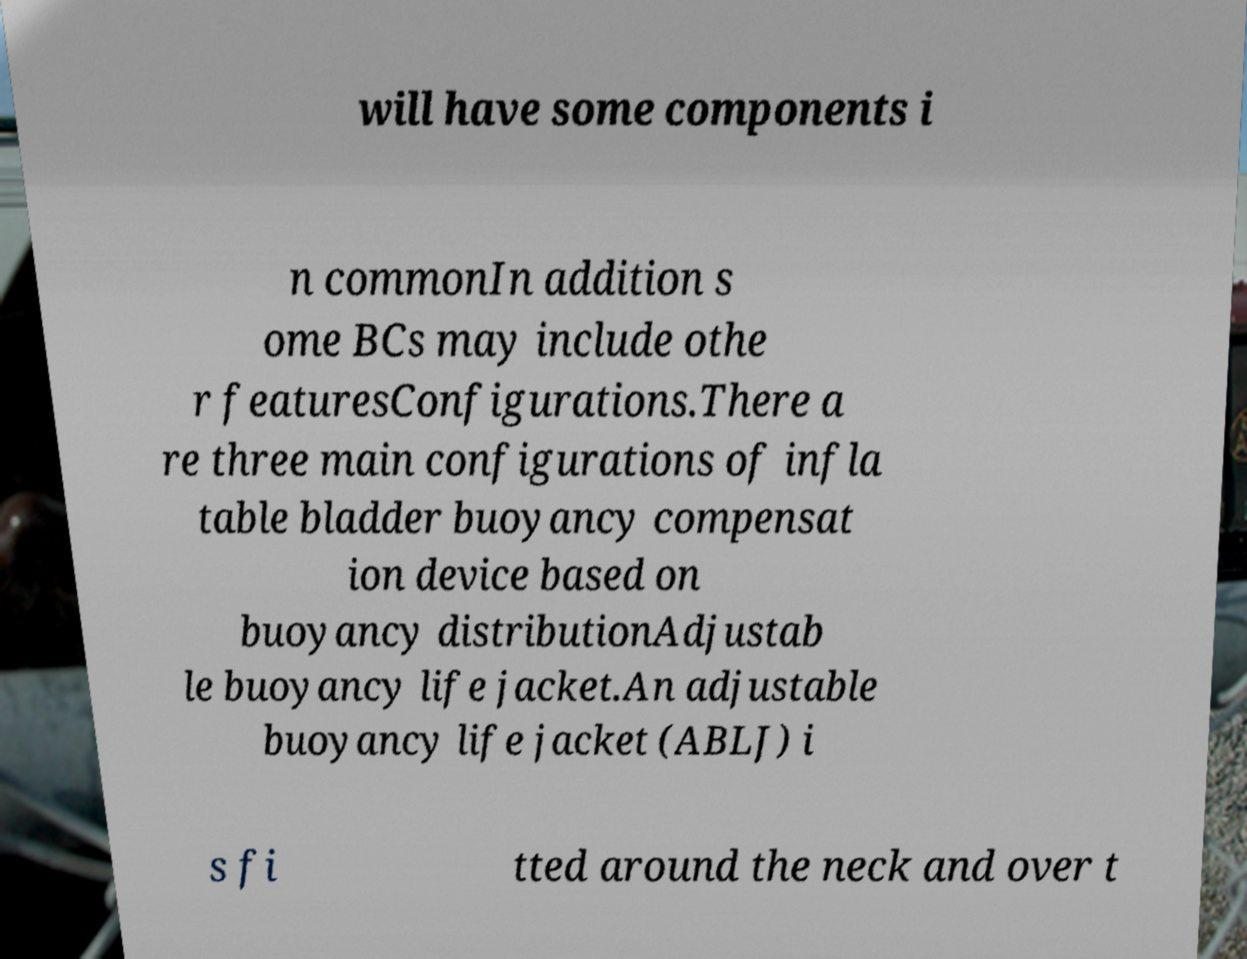Can you read and provide the text displayed in the image?This photo seems to have some interesting text. Can you extract and type it out for me? will have some components i n commonIn addition s ome BCs may include othe r featuresConfigurations.There a re three main configurations of infla table bladder buoyancy compensat ion device based on buoyancy distributionAdjustab le buoyancy life jacket.An adjustable buoyancy life jacket (ABLJ) i s fi tted around the neck and over t 